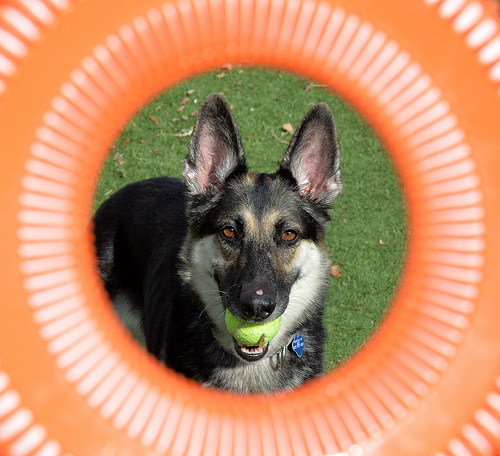<image>
Is the lime in the wolf? No. The lime is not contained within the wolf. These objects have a different spatial relationship. Is there a tube in the dog? No. The tube is not contained within the dog. These objects have a different spatial relationship. 